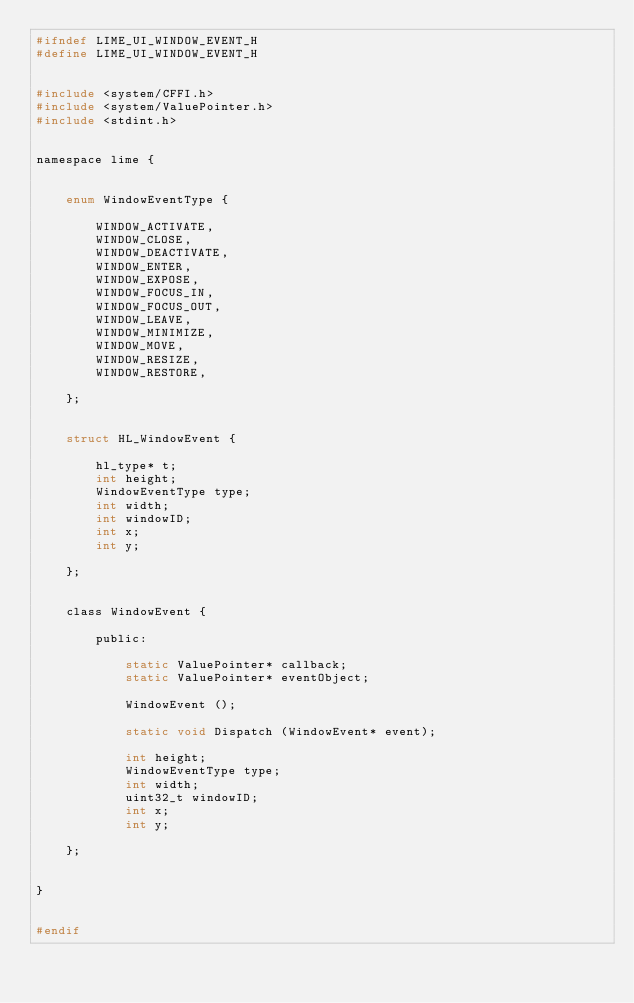Convert code to text. <code><loc_0><loc_0><loc_500><loc_500><_C_>#ifndef LIME_UI_WINDOW_EVENT_H
#define LIME_UI_WINDOW_EVENT_H


#include <system/CFFI.h>
#include <system/ValuePointer.h>
#include <stdint.h>


namespace lime {
	
	
	enum WindowEventType {
		
		WINDOW_ACTIVATE,
		WINDOW_CLOSE,
		WINDOW_DEACTIVATE,
		WINDOW_ENTER,
		WINDOW_EXPOSE,
		WINDOW_FOCUS_IN,
		WINDOW_FOCUS_OUT,
		WINDOW_LEAVE,
		WINDOW_MINIMIZE,
		WINDOW_MOVE,
		WINDOW_RESIZE,
		WINDOW_RESTORE,
		
	};
	
	
	struct HL_WindowEvent {
		
		hl_type* t;
		int height;
		WindowEventType type;
		int width;
		int windowID;
		int x;
		int y;
		
	};
	
	
	class WindowEvent {
		
		public:
			
			static ValuePointer* callback;
			static ValuePointer* eventObject;
			
			WindowEvent ();
			
			static void Dispatch (WindowEvent* event);
			
			int height;
			WindowEventType type;
			int width;
			uint32_t windowID;
			int x;
			int y;
		
	};
	
	
}


#endif</code> 